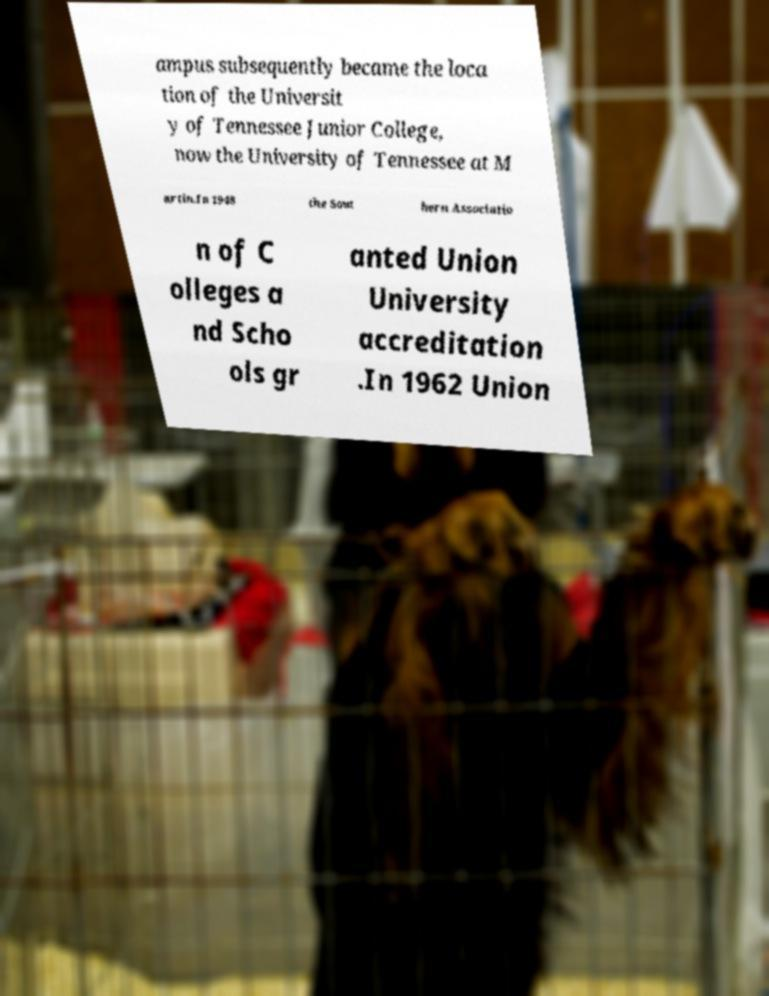I need the written content from this picture converted into text. Can you do that? ampus subsequently became the loca tion of the Universit y of Tennessee Junior College, now the University of Tennessee at M artin.In 1948 the Sout hern Associatio n of C olleges a nd Scho ols gr anted Union University accreditation .In 1962 Union 